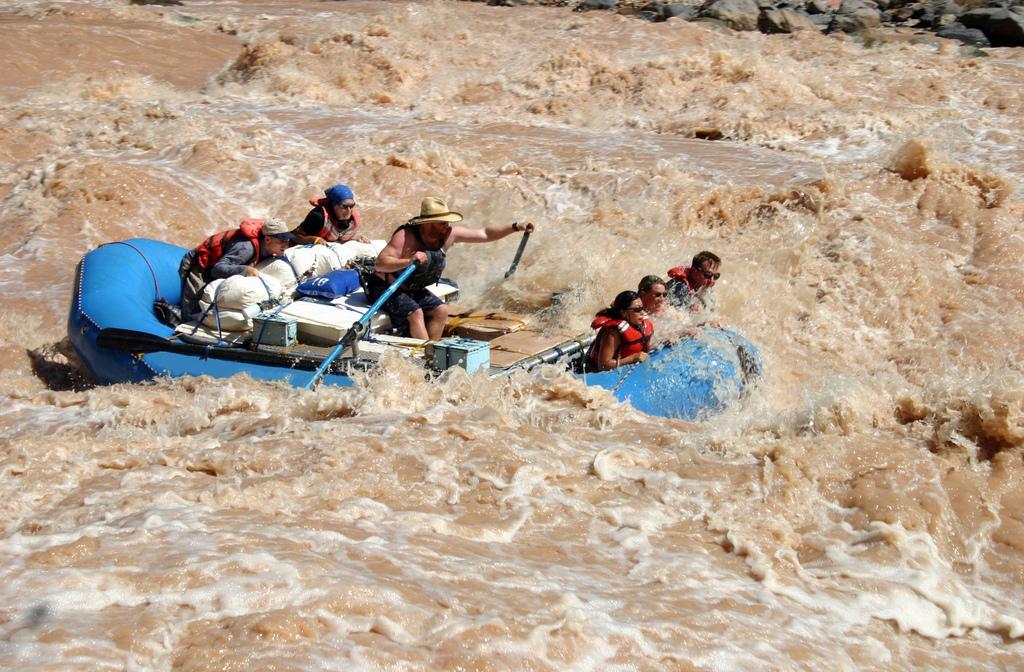Can you describe this image briefly? This picture shows river rafting by six people on the raft 